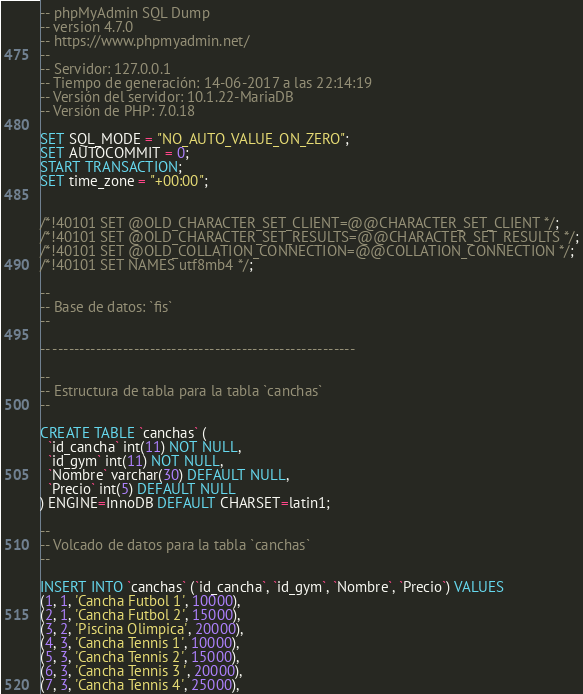Convert code to text. <code><loc_0><loc_0><loc_500><loc_500><_SQL_>-- phpMyAdmin SQL Dump
-- version 4.7.0
-- https://www.phpmyadmin.net/
--
-- Servidor: 127.0.0.1
-- Tiempo de generación: 14-06-2017 a las 22:14:19
-- Versión del servidor: 10.1.22-MariaDB
-- Versión de PHP: 7.0.18

SET SQL_MODE = "NO_AUTO_VALUE_ON_ZERO";
SET AUTOCOMMIT = 0;
START TRANSACTION;
SET time_zone = "+00:00";


/*!40101 SET @OLD_CHARACTER_SET_CLIENT=@@CHARACTER_SET_CLIENT */;
/*!40101 SET @OLD_CHARACTER_SET_RESULTS=@@CHARACTER_SET_RESULTS */;
/*!40101 SET @OLD_COLLATION_CONNECTION=@@COLLATION_CONNECTION */;
/*!40101 SET NAMES utf8mb4 */;

--
-- Base de datos: `fis`
--

-- --------------------------------------------------------

--
-- Estructura de tabla para la tabla `canchas`
--

CREATE TABLE `canchas` (
  `id_cancha` int(11) NOT NULL,
  `id_gym` int(11) NOT NULL,
  `Nombre` varchar(30) DEFAULT NULL,
  `Precio` int(5) DEFAULT NULL
) ENGINE=InnoDB DEFAULT CHARSET=latin1;

--
-- Volcado de datos para la tabla `canchas`
--

INSERT INTO `canchas` (`id_cancha`, `id_gym`, `Nombre`, `Precio`) VALUES
(1, 1, 'Cancha Futbol 1', 10000),
(2, 1, 'Cancha Futbol 2', 15000),
(3, 2, 'Piscina Olimpica', 20000),
(4, 3, 'Cancha Tennis 1', 10000),
(5, 3, 'Cancha Tennis 2', 15000),
(6, 3, 'Cancha Tennis 3 ', 20000),
(7, 3, 'Cancha Tennis 4', 25000),</code> 